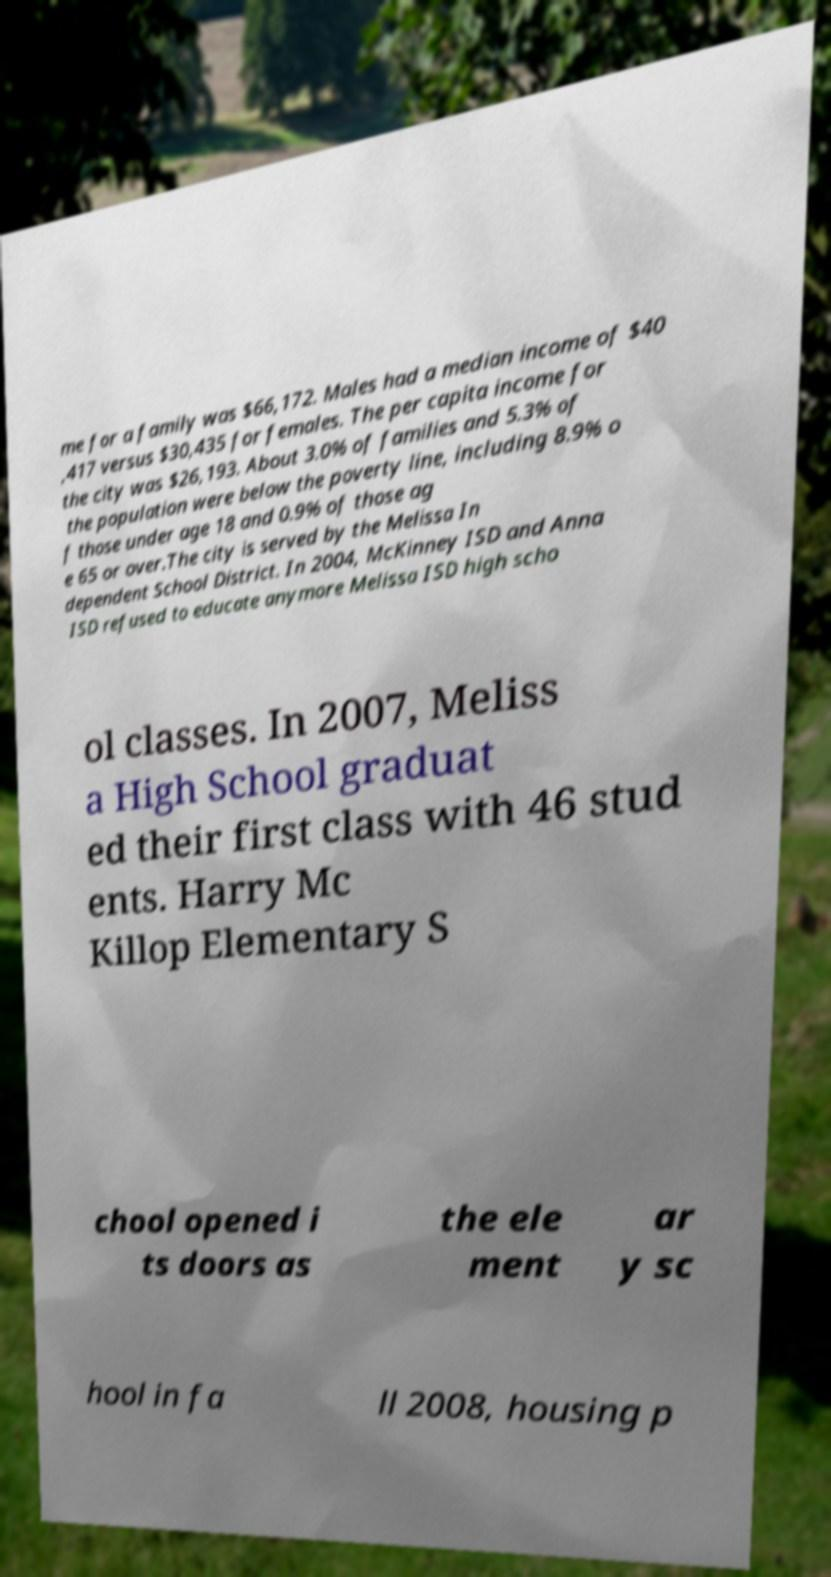Please identify and transcribe the text found in this image. me for a family was $66,172. Males had a median income of $40 ,417 versus $30,435 for females. The per capita income for the city was $26,193. About 3.0% of families and 5.3% of the population were below the poverty line, including 8.9% o f those under age 18 and 0.9% of those ag e 65 or over.The city is served by the Melissa In dependent School District. In 2004, McKinney ISD and Anna ISD refused to educate anymore Melissa ISD high scho ol classes. In 2007, Meliss a High School graduat ed their first class with 46 stud ents. Harry Mc Killop Elementary S chool opened i ts doors as the ele ment ar y sc hool in fa ll 2008, housing p 